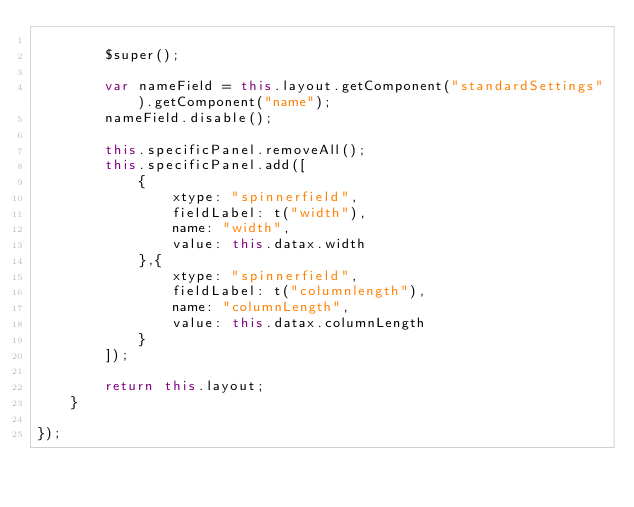Convert code to text. <code><loc_0><loc_0><loc_500><loc_500><_JavaScript_>
        $super();

        var nameField = this.layout.getComponent("standardSettings").getComponent("name");
        nameField.disable();

        this.specificPanel.removeAll();
        this.specificPanel.add([
            {
                xtype: "spinnerfield",
                fieldLabel: t("width"),
                name: "width",
                value: this.datax.width
            },{
                xtype: "spinnerfield",
                fieldLabel: t("columnlength"),
                name: "columnLength",
                value: this.datax.columnLength
            }
        ]);

        return this.layout;
    }

});
</code> 